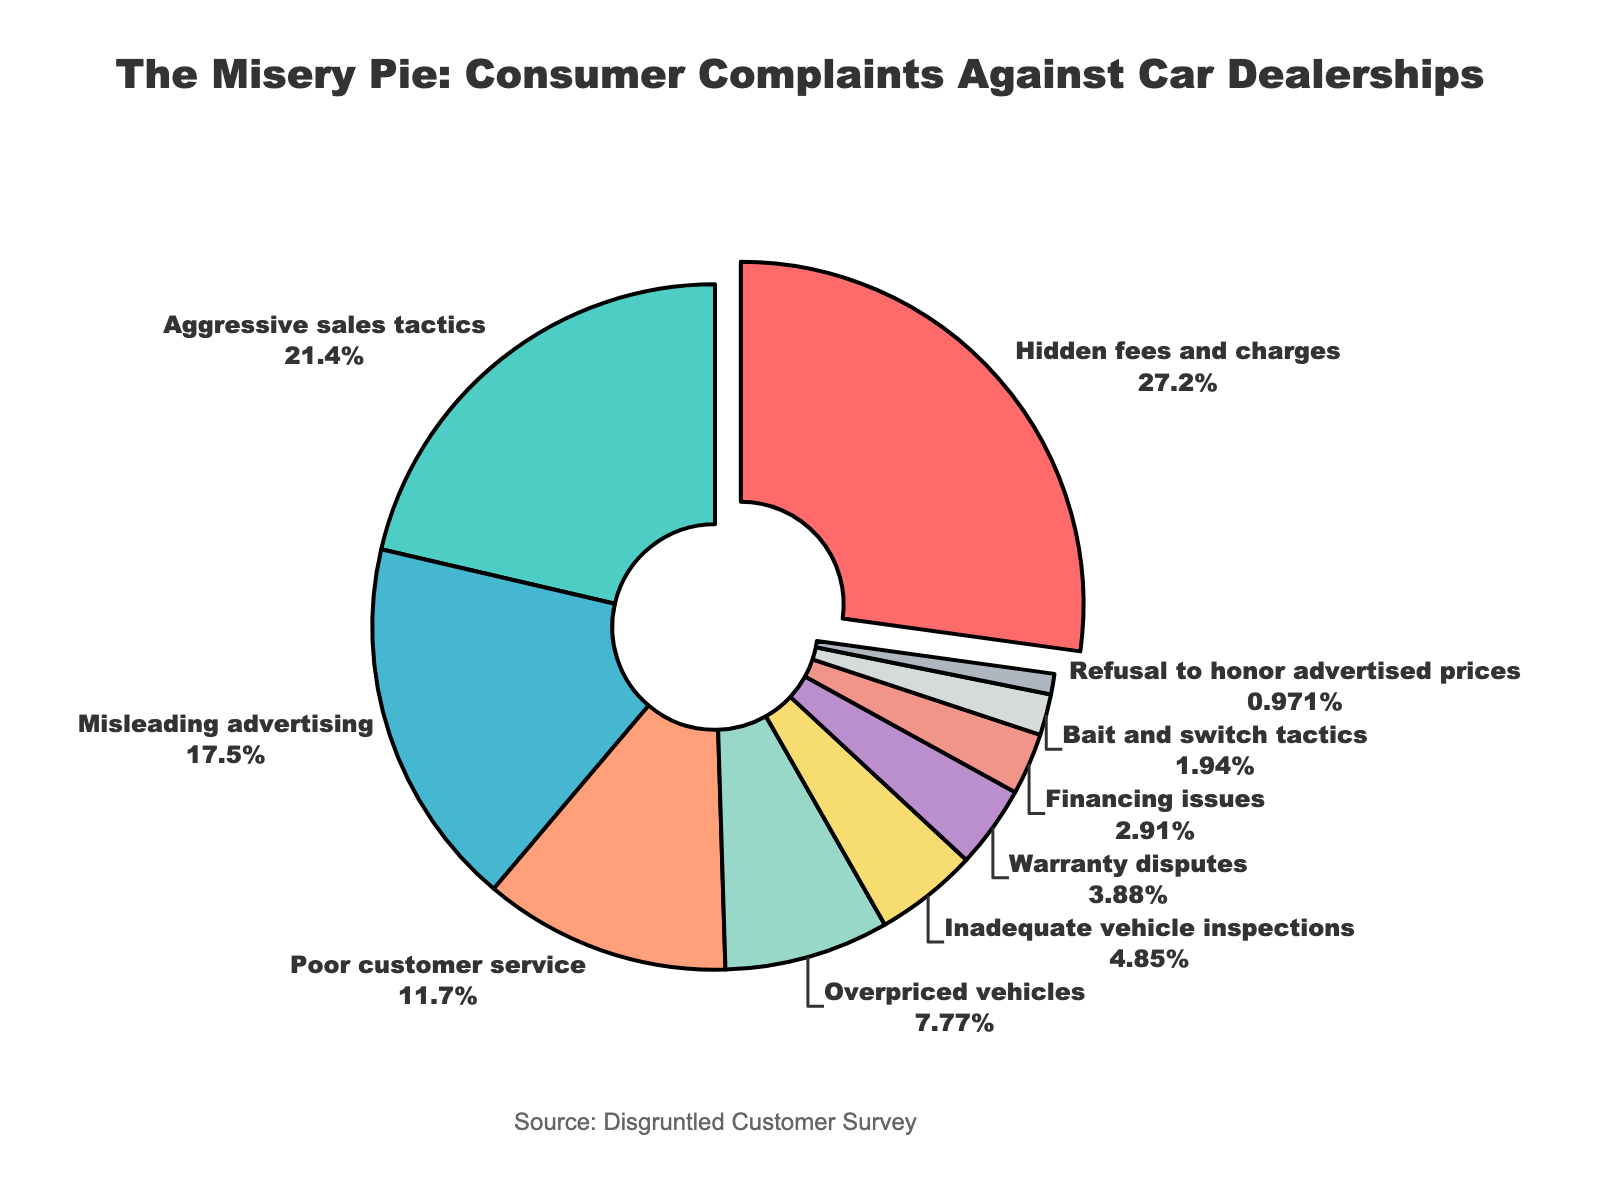What is the most common complaint category? The pie chart shows the percentages for different complaint categories. The slice for "Hidden fees and charges" is the largest, indicating it's the most common complaint at 28%.
Answer: Hidden fees and charges Which complaint category has the smallest percentage? The pie chart indicates that "Refusal to honor advertised prices" has the smallest slice, representing only 1% of the total complaints.
Answer: Refusal to honor advertised prices By how much do complaints about "Aggressive sales tactics" exceed those about "Overpriced vehicles"? According to the pie chart, "Aggressive sales tactics" make up 22% while "Overpriced vehicles" account for 8%. The difference is 22% - 8% = 14%.
Answer: 14% What is the combined percentage of complaints related to "Poor customer service" and "Misleading advertising"? From the chart, "Poor customer service" accounts for 12% and "Misleading advertising" for 18%. Summing them up gives 12% + 18% = 30%.
Answer: 30% Which complaints category is represented by a green slice? By observing the colors of the slices, the green slice corresponds to "Aggressive sales tactics" at 22%.
Answer: Aggressive sales tactics How much of the pie chart is constituted by complaints about hidden fees and charges, and aggressive sales tactics combined? Adding the percentages for "Hidden fees and charges" (28%) and "Aggressive sales tactics" (22%) yields 28% + 22% = 50%.
Answer: 50% Is the percentage of complaints regarding "Warranty disputes" more or less than half of those about "Poor customer service"? "Warranty disputes" account for 4%, and "Poor customer service" is 12%. Half of 12% is 6%, and since 4% is less than 6%, complaints about "Warranty disputes" are less.
Answer: Less Which category is marked by a red slice? By looking at the visual chart, the red slice corresponds to the "Hidden fees and charges" at 28%.
Answer: Hidden fees and charges Compare the percentages of complaints for "Inadequate vehicle inspections" and "Financing issues". Which one is greater and by how much? "Inadequate vehicle inspections" is 5%, while "Financing issues" make up 3%. The difference is 5% - 3% = 2%, with "Inadequate vehicle inspections" being greater.
Answer: Inadequate vehicle inspections, 2% Calculate the average percentage of the categories with single-digit percentages. The single-digit percentage categories are "Overpriced vehicles" (8%), "Inadequate vehicle inspections" (5%), "Warranty disputes" (4%), "Financing issues" (3%), and "Bait and switch" tactics" (2%), and "Refusal to honor advertised prices" (1%). Their sum is 8 + 5 + 4 + 3 + 2 + 1 = 23. There are 6 categories, so the average is 23/6 ≈ 3.83%.
Answer: 3.83% 